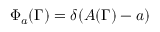Convert formula to latex. <formula><loc_0><loc_0><loc_500><loc_500>\Phi _ { a } ( \Gamma ) = \delta ( A ( \Gamma ) - a )</formula> 